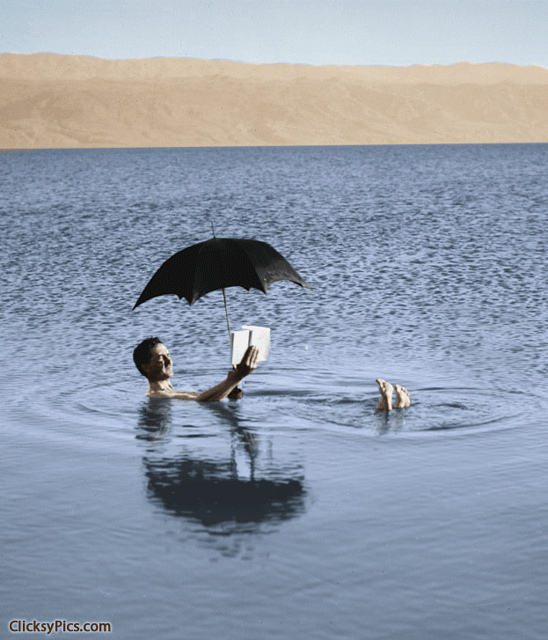Identify the text displayed in this image. ClicksyPics. COM 